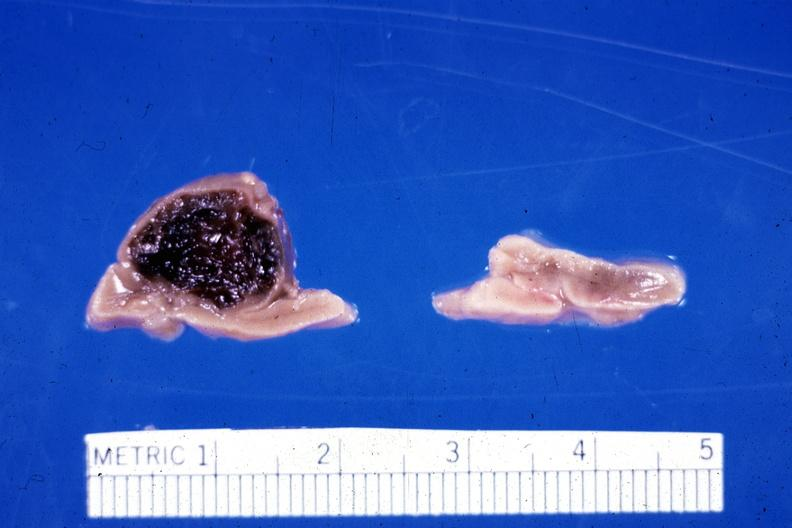does this image show fixed tissue hemorrhage hematoma in left adrenal of premature 30 week gestation gram infant lesion had ruptured causing 20 ml hemoperitoneum unusual lesion?
Answer the question using a single word or phrase. Yes 